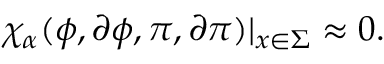Convert formula to latex. <formula><loc_0><loc_0><loc_500><loc_500>\chi _ { \alpha } ( \phi , \partial \phi , \pi , \partial \pi ) | _ { x \in \Sigma } \approx 0 .</formula> 